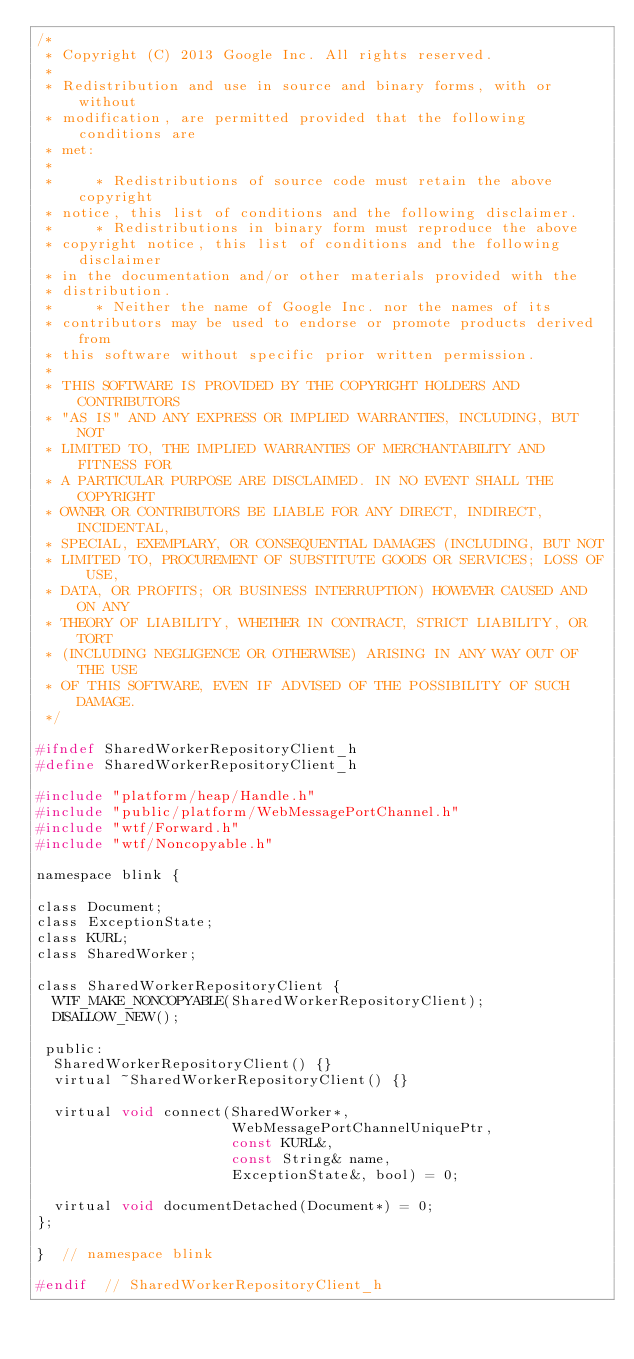Convert code to text. <code><loc_0><loc_0><loc_500><loc_500><_C_>/*
 * Copyright (C) 2013 Google Inc. All rights reserved.
 *
 * Redistribution and use in source and binary forms, with or without
 * modification, are permitted provided that the following conditions are
 * met:
 *
 *     * Redistributions of source code must retain the above copyright
 * notice, this list of conditions and the following disclaimer.
 *     * Redistributions in binary form must reproduce the above
 * copyright notice, this list of conditions and the following disclaimer
 * in the documentation and/or other materials provided with the
 * distribution.
 *     * Neither the name of Google Inc. nor the names of its
 * contributors may be used to endorse or promote products derived from
 * this software without specific prior written permission.
 *
 * THIS SOFTWARE IS PROVIDED BY THE COPYRIGHT HOLDERS AND CONTRIBUTORS
 * "AS IS" AND ANY EXPRESS OR IMPLIED WARRANTIES, INCLUDING, BUT NOT
 * LIMITED TO, THE IMPLIED WARRANTIES OF MERCHANTABILITY AND FITNESS FOR
 * A PARTICULAR PURPOSE ARE DISCLAIMED. IN NO EVENT SHALL THE COPYRIGHT
 * OWNER OR CONTRIBUTORS BE LIABLE FOR ANY DIRECT, INDIRECT, INCIDENTAL,
 * SPECIAL, EXEMPLARY, OR CONSEQUENTIAL DAMAGES (INCLUDING, BUT NOT
 * LIMITED TO, PROCUREMENT OF SUBSTITUTE GOODS OR SERVICES; LOSS OF USE,
 * DATA, OR PROFITS; OR BUSINESS INTERRUPTION) HOWEVER CAUSED AND ON ANY
 * THEORY OF LIABILITY, WHETHER IN CONTRACT, STRICT LIABILITY, OR TORT
 * (INCLUDING NEGLIGENCE OR OTHERWISE) ARISING IN ANY WAY OUT OF THE USE
 * OF THIS SOFTWARE, EVEN IF ADVISED OF THE POSSIBILITY OF SUCH DAMAGE.
 */

#ifndef SharedWorkerRepositoryClient_h
#define SharedWorkerRepositoryClient_h

#include "platform/heap/Handle.h"
#include "public/platform/WebMessagePortChannel.h"
#include "wtf/Forward.h"
#include "wtf/Noncopyable.h"

namespace blink {

class Document;
class ExceptionState;
class KURL;
class SharedWorker;

class SharedWorkerRepositoryClient {
  WTF_MAKE_NONCOPYABLE(SharedWorkerRepositoryClient);
  DISALLOW_NEW();

 public:
  SharedWorkerRepositoryClient() {}
  virtual ~SharedWorkerRepositoryClient() {}

  virtual void connect(SharedWorker*,
                       WebMessagePortChannelUniquePtr,
                       const KURL&,
                       const String& name,
                       ExceptionState&, bool) = 0;

  virtual void documentDetached(Document*) = 0;
};

}  // namespace blink

#endif  // SharedWorkerRepositoryClient_h
</code> 